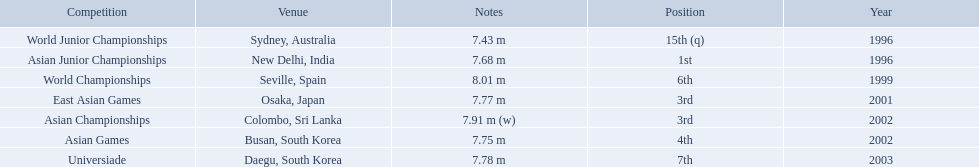What jumps did huang le make in 2002? 7.91 m (w), 7.75 m. Which jump was the longest? 7.91 m (w). What are the competitions that huang le participated in? World Junior Championships, Asian Junior Championships, World Championships, East Asian Games, Asian Championships, Asian Games, Universiade. Which competitions did he participate in 2002 Asian Championships, Asian Games. What are the lengths of his jumps that year? 7.91 m (w), 7.75 m. What is the longest length of a jump? 7.91 m (w). 